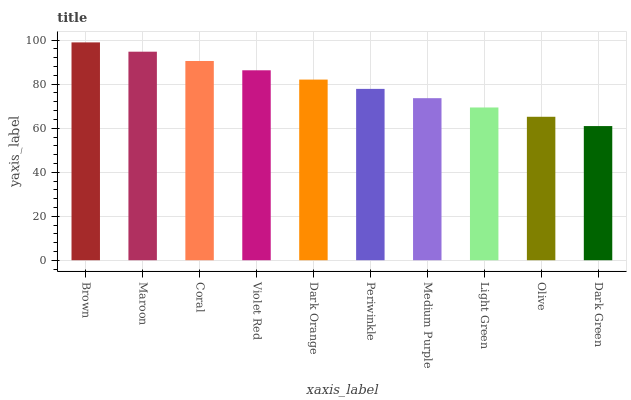Is Dark Green the minimum?
Answer yes or no. Yes. Is Brown the maximum?
Answer yes or no. Yes. Is Maroon the minimum?
Answer yes or no. No. Is Maroon the maximum?
Answer yes or no. No. Is Brown greater than Maroon?
Answer yes or no. Yes. Is Maroon less than Brown?
Answer yes or no. Yes. Is Maroon greater than Brown?
Answer yes or no. No. Is Brown less than Maroon?
Answer yes or no. No. Is Dark Orange the high median?
Answer yes or no. Yes. Is Periwinkle the low median?
Answer yes or no. Yes. Is Light Green the high median?
Answer yes or no. No. Is Coral the low median?
Answer yes or no. No. 